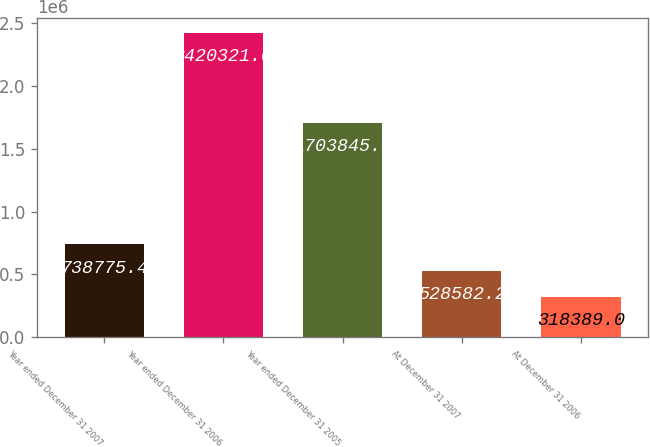<chart> <loc_0><loc_0><loc_500><loc_500><bar_chart><fcel>Year ended December 31 2007<fcel>Year ended December 31 2006<fcel>Year ended December 31 2005<fcel>At December 31 2007<fcel>At December 31 2006<nl><fcel>738775<fcel>2.42032e+06<fcel>1.70384e+06<fcel>528582<fcel>318389<nl></chart> 